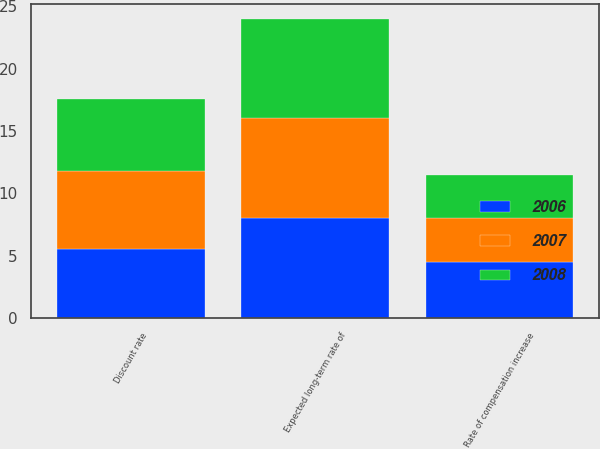<chart> <loc_0><loc_0><loc_500><loc_500><stacked_bar_chart><ecel><fcel>Discount rate<fcel>Expected long-term rate of<fcel>Rate of compensation increase<nl><fcel>2007<fcel>6.3<fcel>8<fcel>3.5<nl><fcel>2008<fcel>5.8<fcel>8<fcel>3.5<nl><fcel>2006<fcel>5.5<fcel>8<fcel>4.5<nl></chart> 